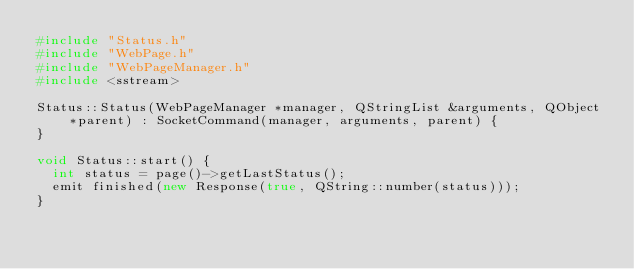Convert code to text. <code><loc_0><loc_0><loc_500><loc_500><_C++_>#include "Status.h"
#include "WebPage.h"
#include "WebPageManager.h"
#include <sstream>

Status::Status(WebPageManager *manager, QStringList &arguments, QObject *parent) : SocketCommand(manager, arguments, parent) {
}

void Status::start() {
  int status = page()->getLastStatus();
  emit finished(new Response(true, QString::number(status)));
}

</code> 